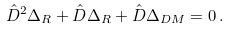<formula> <loc_0><loc_0><loc_500><loc_500>\hat { D } ^ { 2 } \Delta _ { R } + \hat { D } \Delta _ { R } + \hat { D } \Delta _ { D M } = 0 \, .</formula> 